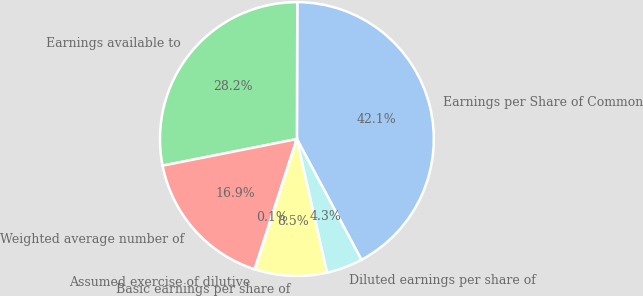<chart> <loc_0><loc_0><loc_500><loc_500><pie_chart><fcel>Earnings per Share of Common<fcel>Earnings available to<fcel>Weighted average number of<fcel>Assumed exercise of dilutive<fcel>Basic earnings per share of<fcel>Diluted earnings per share of<nl><fcel>42.14%<fcel>28.16%<fcel>16.89%<fcel>0.06%<fcel>8.48%<fcel>4.27%<nl></chart> 